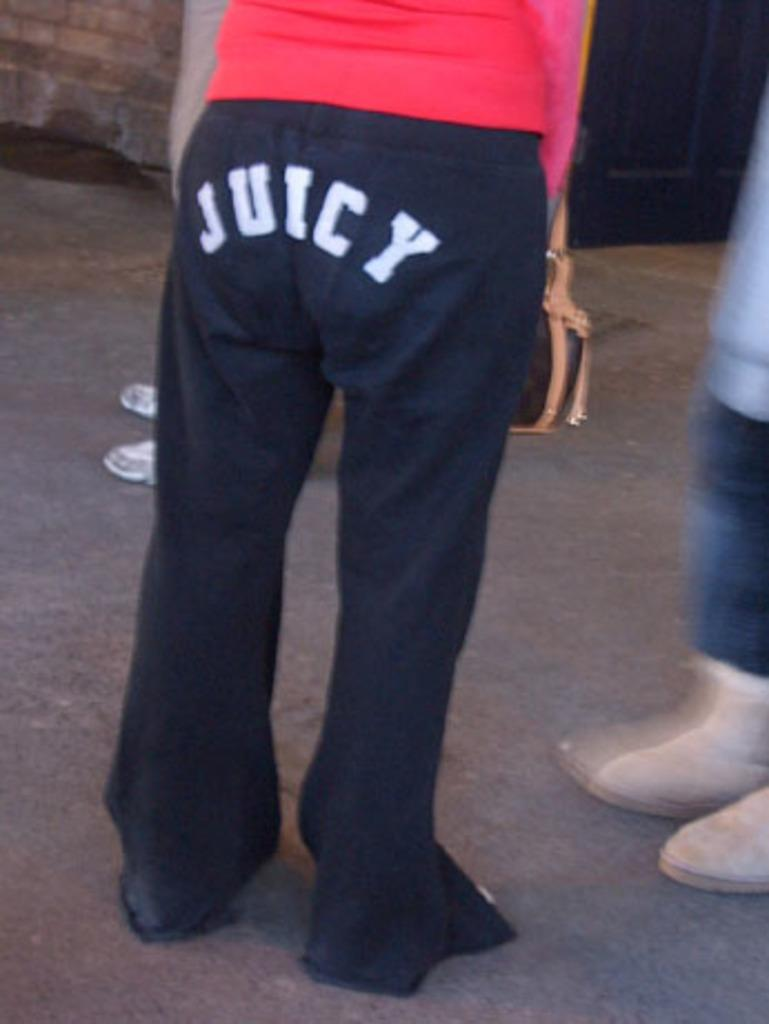<image>
Write a terse but informative summary of the picture. A person wears a pair of black pants that read "JUICY." 